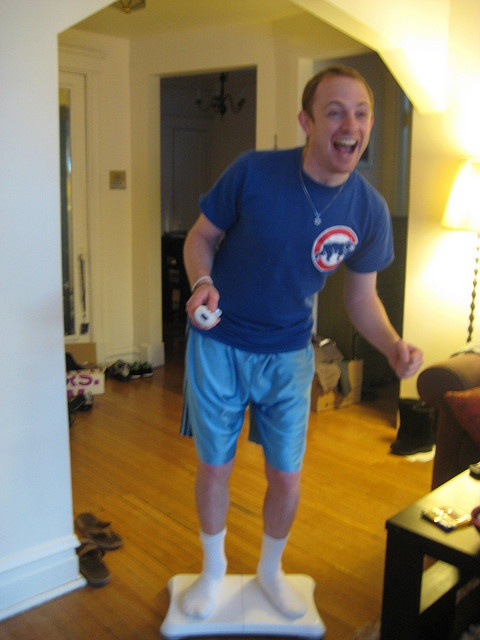Describe the objects in this image and their specific colors. I can see people in darkgray, navy, gray, blue, and brown tones, couch in darkgray, black, maroon, and olive tones, remote in darkgray, khaki, black, and tan tones, and remote in darkgray and gray tones in this image. 